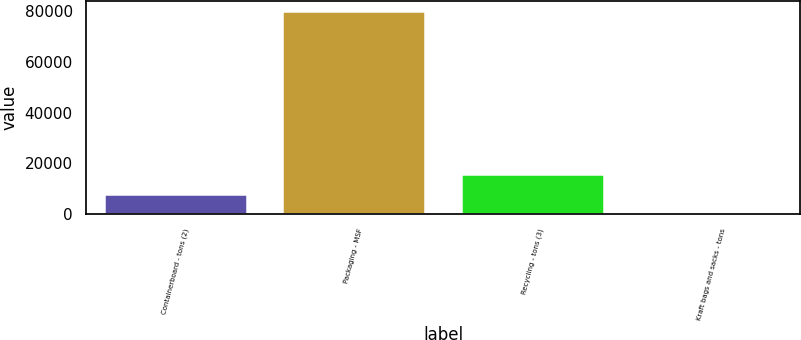Convert chart. <chart><loc_0><loc_0><loc_500><loc_500><bar_chart><fcel>Containerboard - tons (2)<fcel>Packaging - MSF<fcel>Recycling - tons (3)<fcel>Kraft bags and sacks - tons<nl><fcel>8058.9<fcel>79851<fcel>16035.8<fcel>82<nl></chart> 